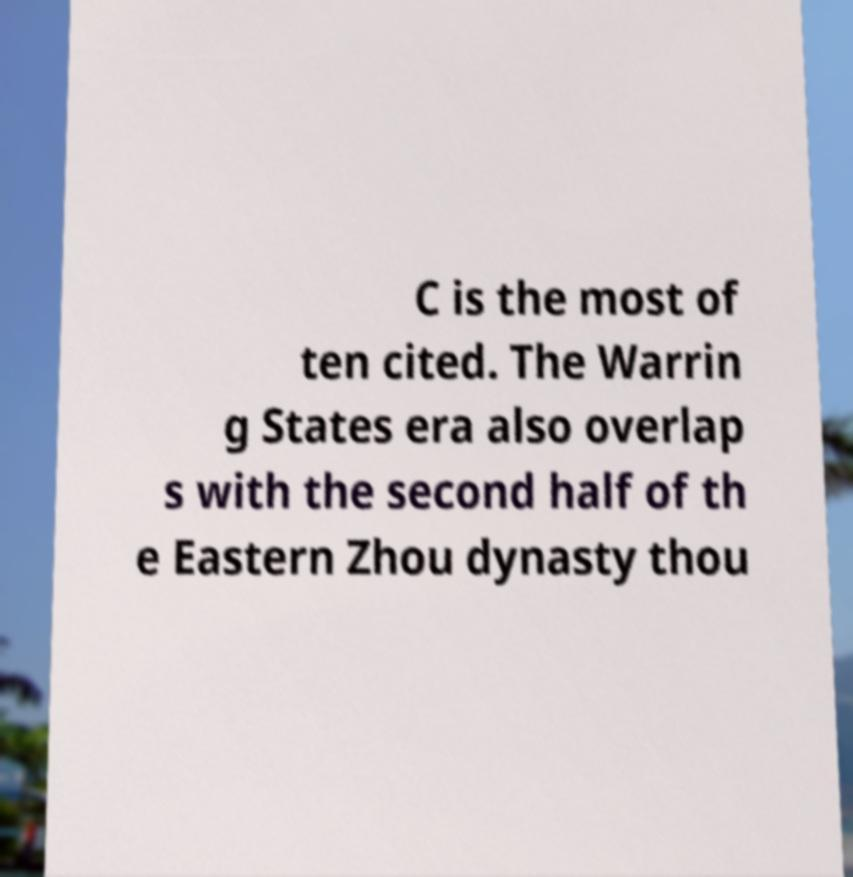Can you accurately transcribe the text from the provided image for me? C is the most of ten cited. The Warrin g States era also overlap s with the second half of th e Eastern Zhou dynasty thou 